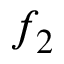Convert formula to latex. <formula><loc_0><loc_0><loc_500><loc_500>f _ { 2 }</formula> 